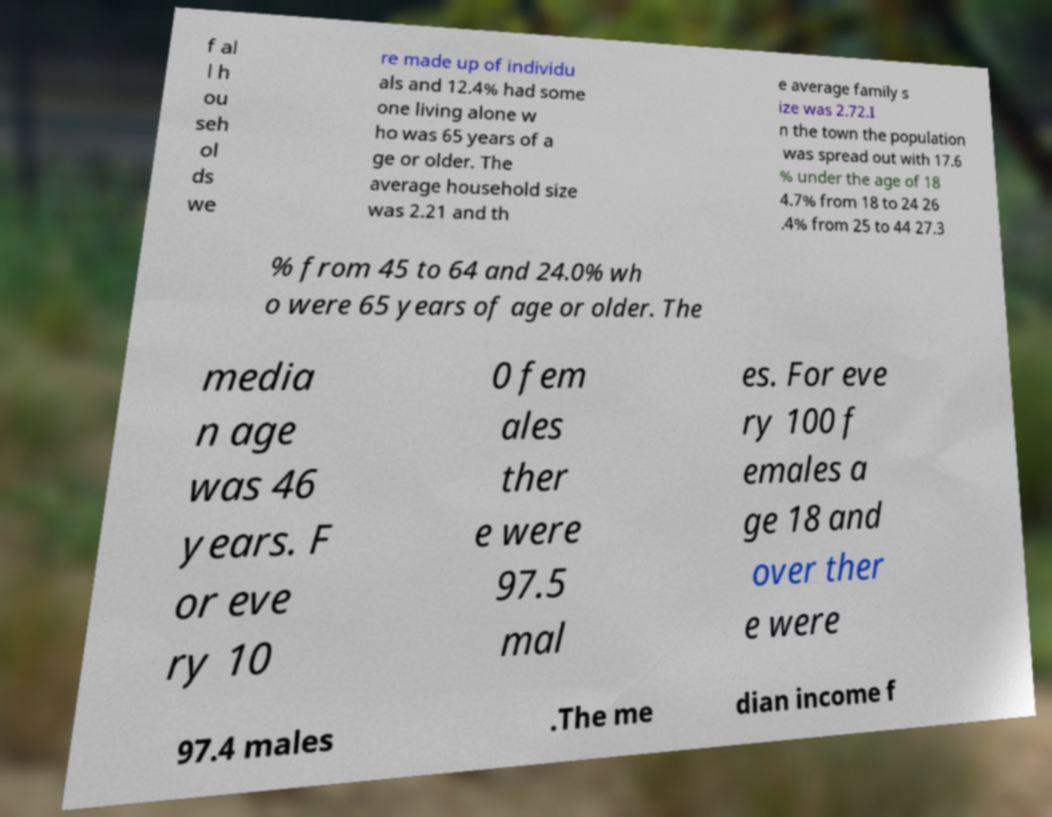Could you extract and type out the text from this image? f al l h ou seh ol ds we re made up of individu als and 12.4% had some one living alone w ho was 65 years of a ge or older. The average household size was 2.21 and th e average family s ize was 2.72.I n the town the population was spread out with 17.6 % under the age of 18 4.7% from 18 to 24 26 .4% from 25 to 44 27.3 % from 45 to 64 and 24.0% wh o were 65 years of age or older. The media n age was 46 years. F or eve ry 10 0 fem ales ther e were 97.5 mal es. For eve ry 100 f emales a ge 18 and over ther e were 97.4 males .The me dian income f 